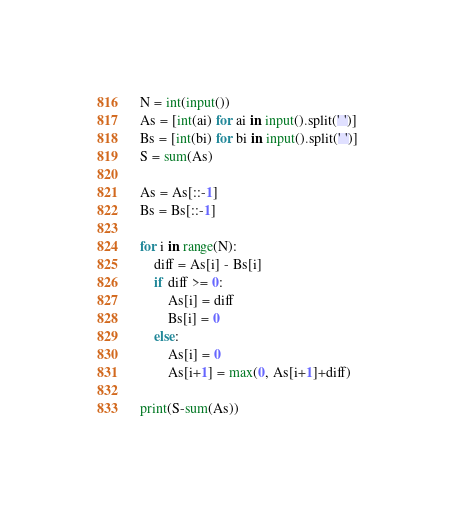Convert code to text. <code><loc_0><loc_0><loc_500><loc_500><_Python_>N = int(input())
As = [int(ai) for ai in input().split(' ')]
Bs = [int(bi) for bi in input().split(' ')]
S = sum(As)

As = As[::-1]
Bs = Bs[::-1]

for i in range(N):
    diff = As[i] - Bs[i]
    if diff >= 0:
        As[i] = diff
        Bs[i] = 0
    else:
        As[i] = 0
        As[i+1] = max(0, As[i+1]+diff)

print(S-sum(As))</code> 